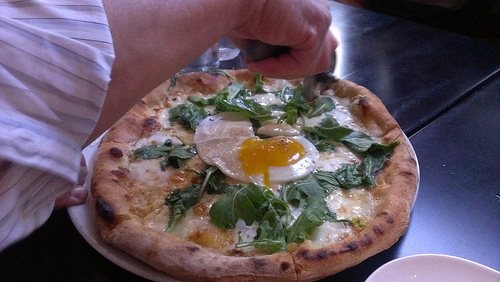Do you see both plates and tables? Yes, both plates and a table are visible in the image. 